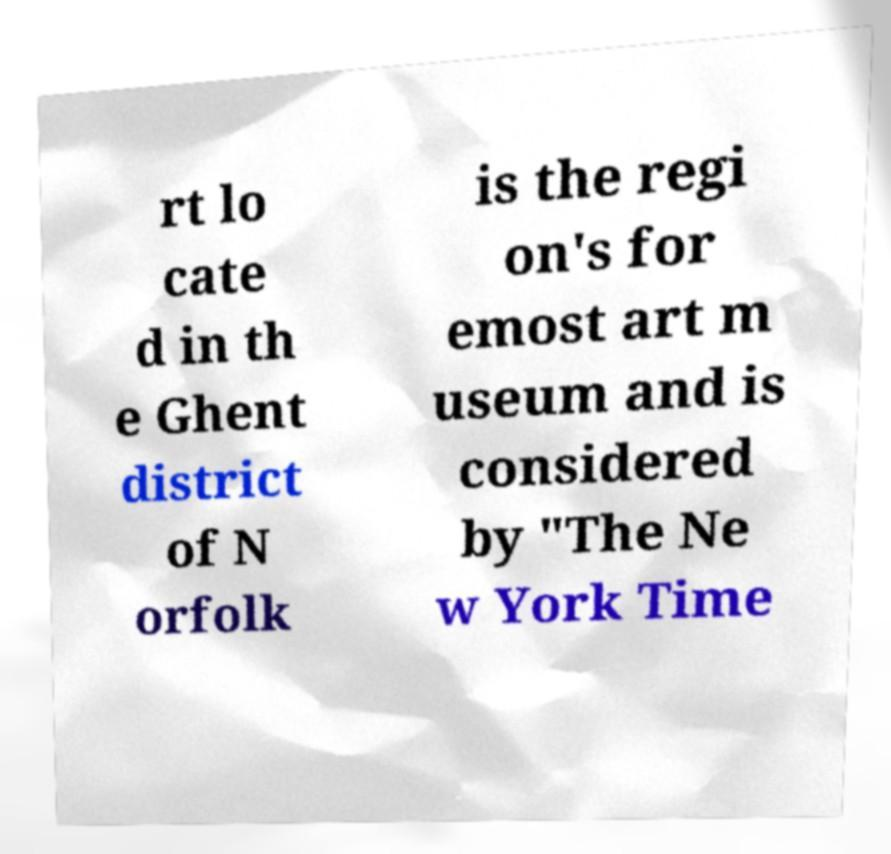Can you accurately transcribe the text from the provided image for me? rt lo cate d in th e Ghent district of N orfolk is the regi on's for emost art m useum and is considered by "The Ne w York Time 